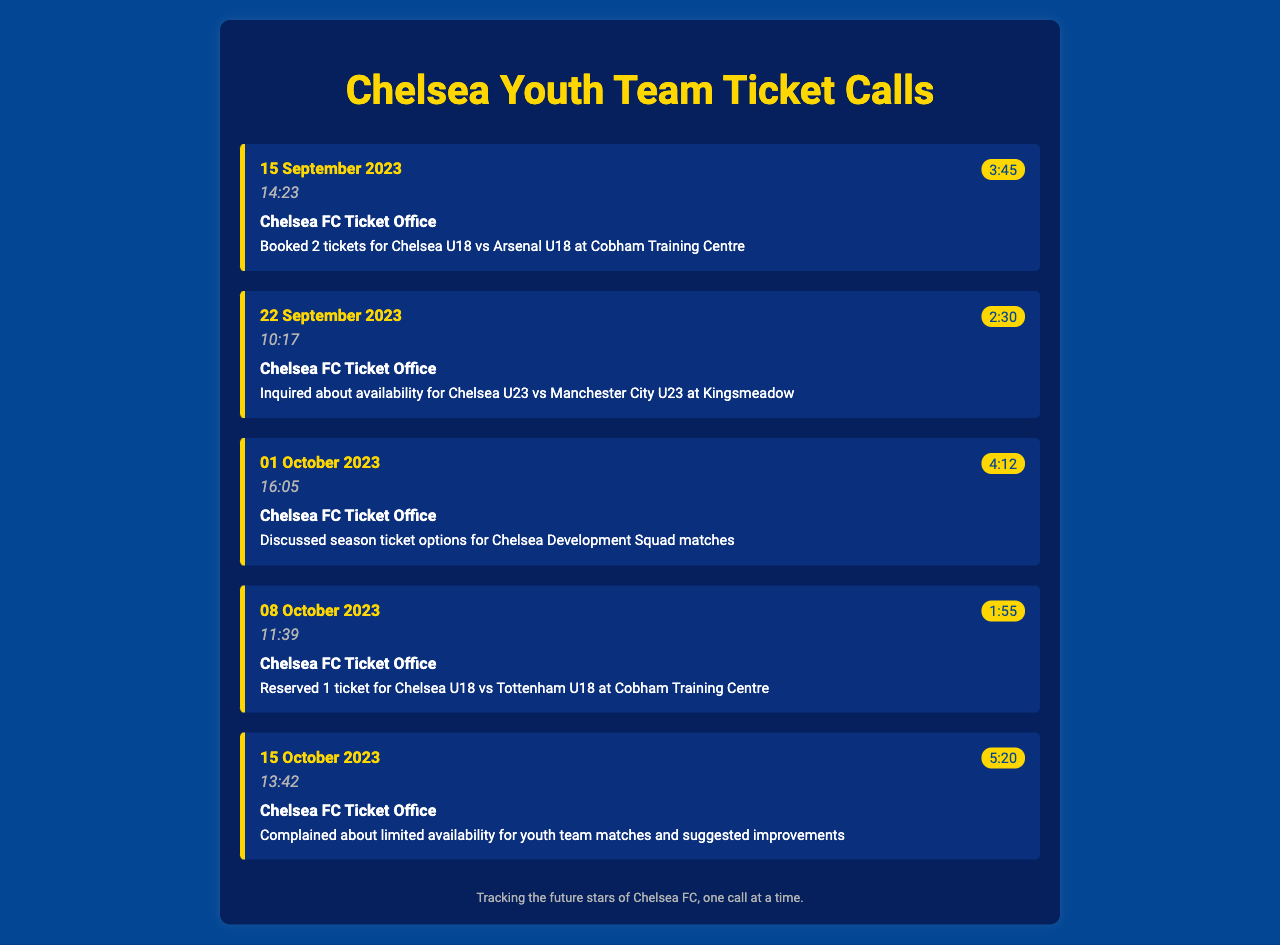what date was the call to book tickets for the match against Arsenal U18? The call to book tickets for the match against Arsenal U18 took place on 15 September 2023.
Answer: 15 September 2023 how many tickets were booked for the Chelsea U18 vs Tottenham U18 match? One ticket was reserved for the Chelsea U18 vs Tottenham U18 match.
Answer: 1 ticket what is the duration of the call discussing season ticket options? The duration of the call discussing season ticket options was 4 minutes and 12 seconds.
Answer: 4:12 when did the complaint about limited availability occur? The complaint about limited availability for youth team matches occurred on 15 October 2023.
Answer: 15 October 2023 who was the contact for all calls listed in the document? All calls were made to the Chelsea FC Ticket Office.
Answer: Chelsea FC Ticket Office what was the purpose of the call on 22 September 2023? The call on 22 September 2023 was to inquire about availability for a specific match.
Answer: Inquired about availability how long was the longest call recorded in the document? The longest call recorded had a duration of 5 minutes and 20 seconds.
Answer: 5:20 what match was discussed in the call on 01 October 2023? The call on 01 October 2023 discussed season ticket options for Chelsea Development Squad matches.
Answer: Chelsea Development Squad matches what is a specific suggestion mentioned in the calls? A suggestion mentioned was improvements for limited availability for youth team matches.
Answer: Suggested improvements 